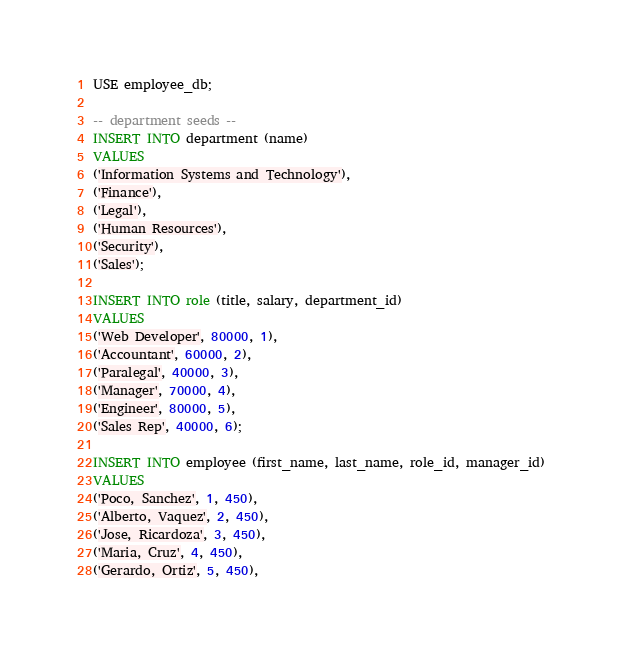<code> <loc_0><loc_0><loc_500><loc_500><_SQL_>USE employee_db;

-- department seeds --
INSERT INTO department (name)
VALUES
('Information Systems and Technology'),
('Finance'),
('Legal'),
('Human Resources'),
('Security'),
('Sales');

INSERT INTO role (title, salary, department_id)
VALUES
('Web Developer', 80000, 1),
('Accountant', 60000, 2),
('Paralegal', 40000, 3),
('Manager', 70000, 4),
('Engineer', 80000, 5),
('Sales Rep', 40000, 6);

INSERT INTO employee (first_name, last_name, role_id, manager_id)
VALUES
('Poco, Sanchez', 1, 450),
('Alberto, Vaquez', 2, 450),
('Jose, Ricardoza', 3, 450),
('Maria, Cruz', 4, 450),
('Gerardo, Ortiz', 5, 450),</code> 